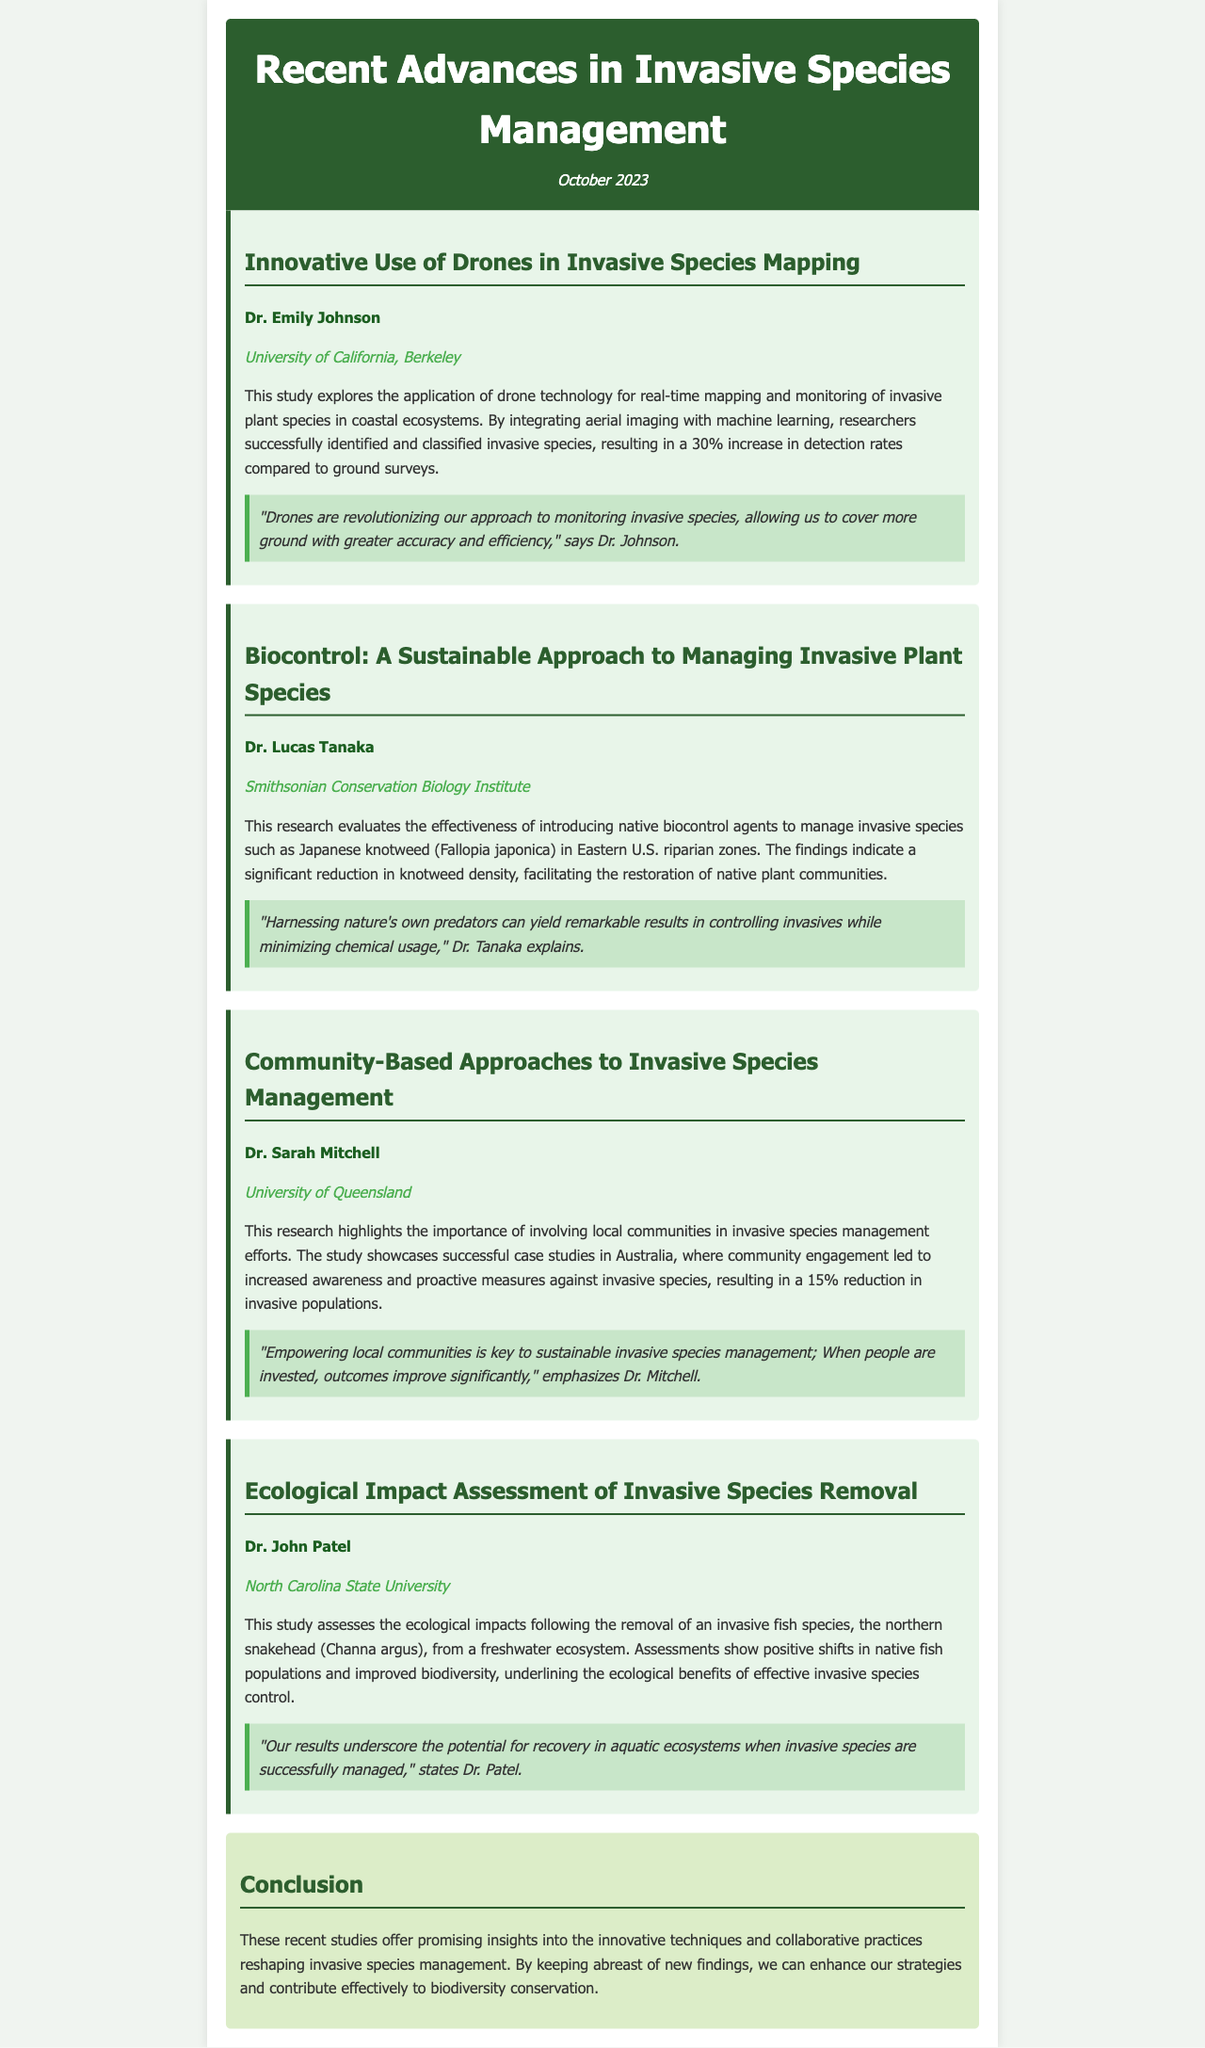What is the title of the newsletter? The title is prominently displayed at the top of the document.
Answer: Recent Advances in Invasive Species Management Who conducted the study on drone technology? The document lists the researcher associated with the drone study.
Answer: Dr. Emily Johnson What invasive plant species was specifically mentioned in Dr. Tanaka's research? The document describes the focus of Dr. Tanaka's study on invasive species.
Answer: Japanese knotweed Which institution is Dr. Sarah Mitchell affiliated with? The document provides institutional affiliations for each researcher.
Answer: University of Queensland What percentage increase in detection rates was achieved through drone technology? The document includes numerical findings from Dr. Johnson's study.
Answer: 30% What was the ecological focus of Dr. Patel's study? The document summarizes the main ecological aspect being investigated by Dr. Patel.
Answer: Freshwater ecosystem What is emphasized as key to sustainable invasive species management by Dr. Mitchell? The document includes a quote that highlights an important factor in invasive species management.
Answer: Empowering local communities What type of approaches does the research by Dr. Sarah Mitchell highlight? The document categorizes the various methodologies discussed in the studies.
Answer: Community-Based Approaches What overall theme do the studies in the newsletter contribute to? The conclusion of the document provides insight into the broader impact of the research findings.
Answer: Biodiversity conservation 